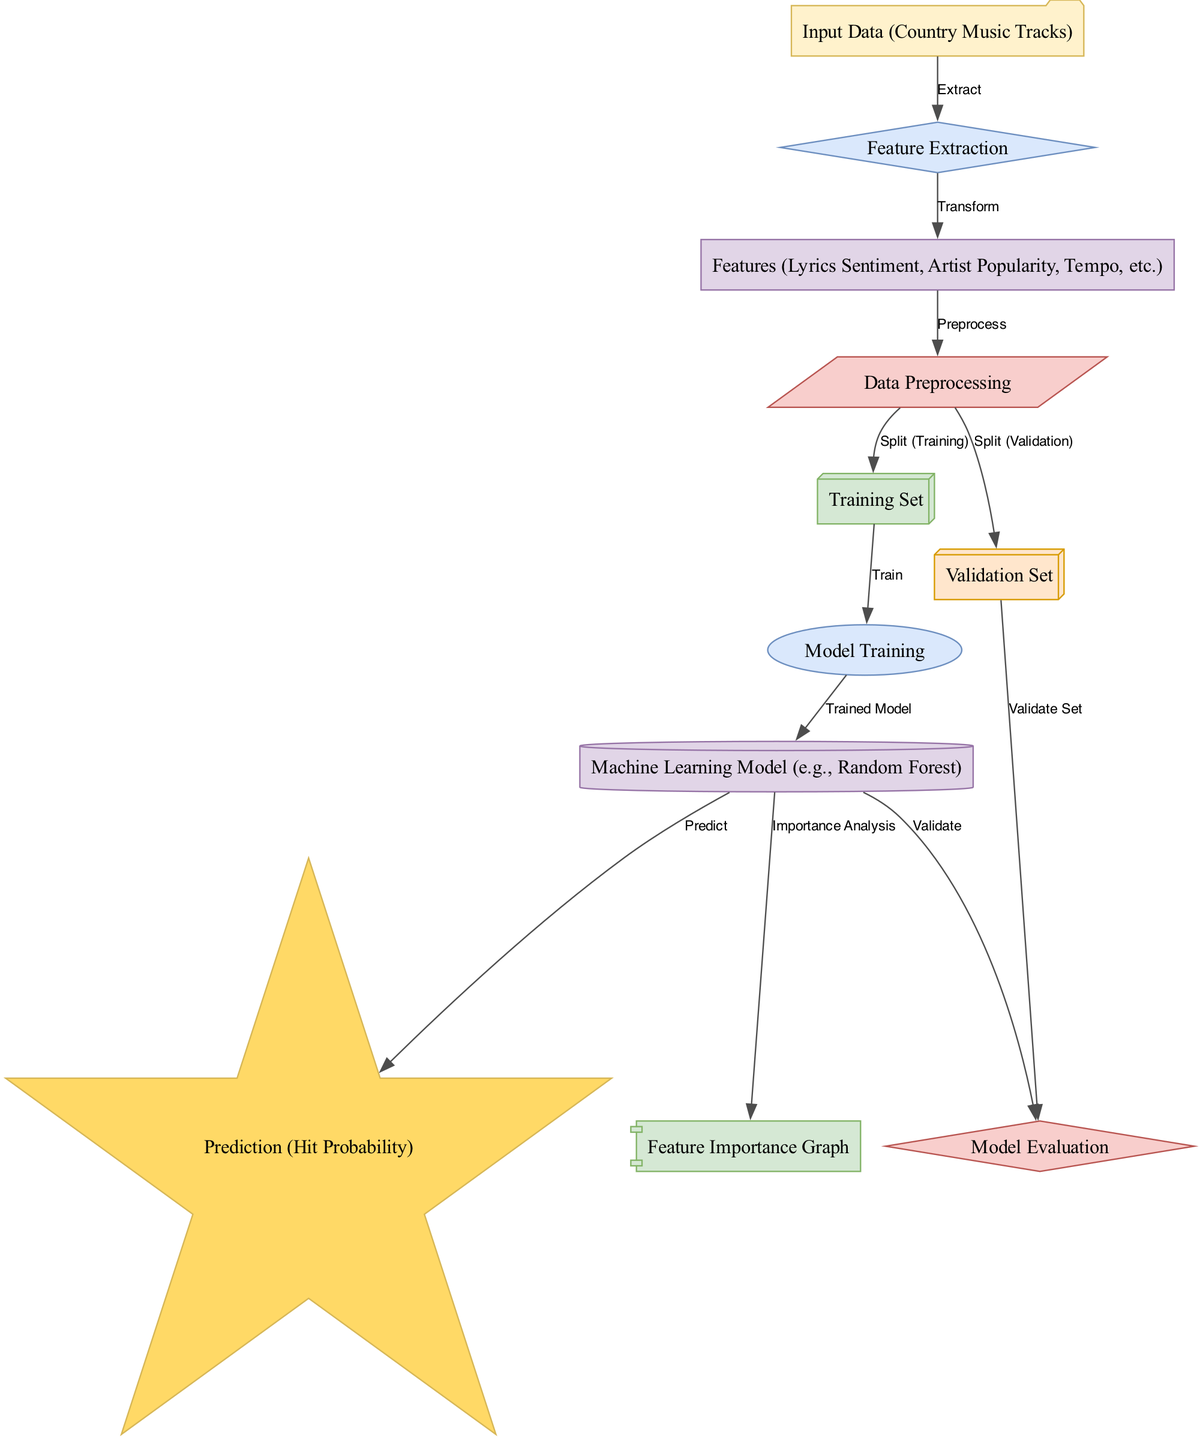What is the first node in the diagram? The first node in the diagram is labeled "Input Data (Country Music Tracks)" which serves as the initial stage for the diagram.
Answer: Input Data (Country Music Tracks) How many features are mentioned in the features node? The features node presents three primary features: Lyrics Sentiment, Artist Popularity, and Tempo, amounting to three distinct features.
Answer: Three What type of machine learning model is used? The diagram specifies that a "Random Forest" model is used in the implementation, indicating the type of algorithm employed for predictions.
Answer: Random Forest What connection is made between the training set and the model training? The training set is connected to the model training with an edge labeled "Train," indicating that data from the training set is utilized to train the model.
Answer: Train What is the output of the model evaluation node? The model evaluation node essentially leads to the prediction node, determining the likelihood of a track becoming a hit based on processed inputs.
Answer: Prediction (Hit Probability) What are the two sets created during data preprocessing? The data preprocessing node splits the data into a training set and a validation set, which are the two distinct subsets created for model training and evaluation.
Answer: Training Set and Validation Set Which node follows the feature importance node? The feature importance node does not lead to another node and instead serves as a terminal node for analyzing the significance of various features in the model.
Answer: None How does the model predict the likelihood of hit songs? The model predicts the likelihood of hit songs by using the trained ML model on the processed features of the incoming tracks, resulting in a predicted probability output.
Answer: By Using the Trained ML Model How are features transformed from data preprocessing? The features are transformed after feature extraction and are then subjected to data preprocessing before being used in the training and validation sets.
Answer: Preprocess 